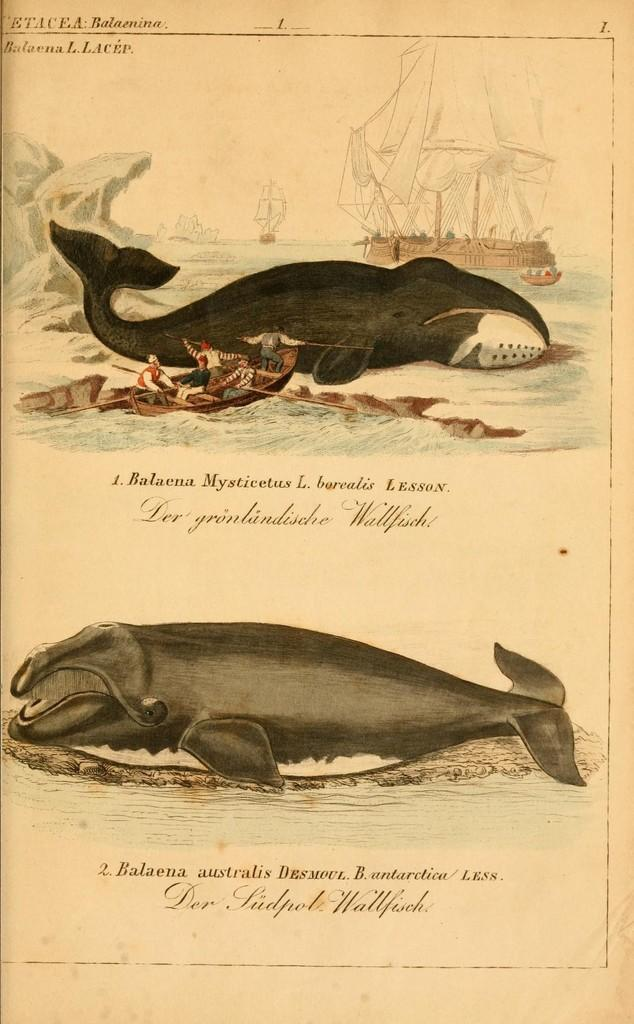What is the medium of the image? The image is on a paper. What animals are depicted in the image? There are images of two whales in the image. What activity is taking place in the image? There are persons rowing a boat in the image. What other object is present in the image? There is a ship on the right side of the image. How is the ship positioned in the image? The ship is in the water on the right side of the image. What type of leaf is being used as a sail for the boat in the image? There is no leaf being used as a sail for the boat in the image; it is being rowed by persons. 